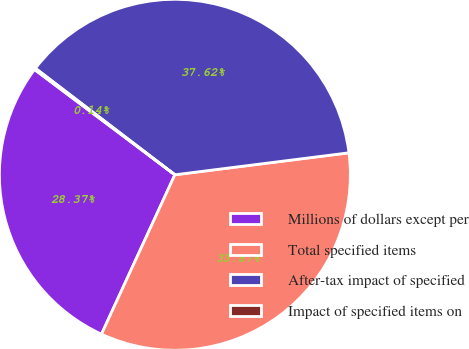<chart> <loc_0><loc_0><loc_500><loc_500><pie_chart><fcel>Millions of dollars except per<fcel>Total specified items<fcel>After-tax impact of specified<fcel>Impact of specified items on<nl><fcel>28.37%<fcel>33.87%<fcel>37.62%<fcel>0.14%<nl></chart> 